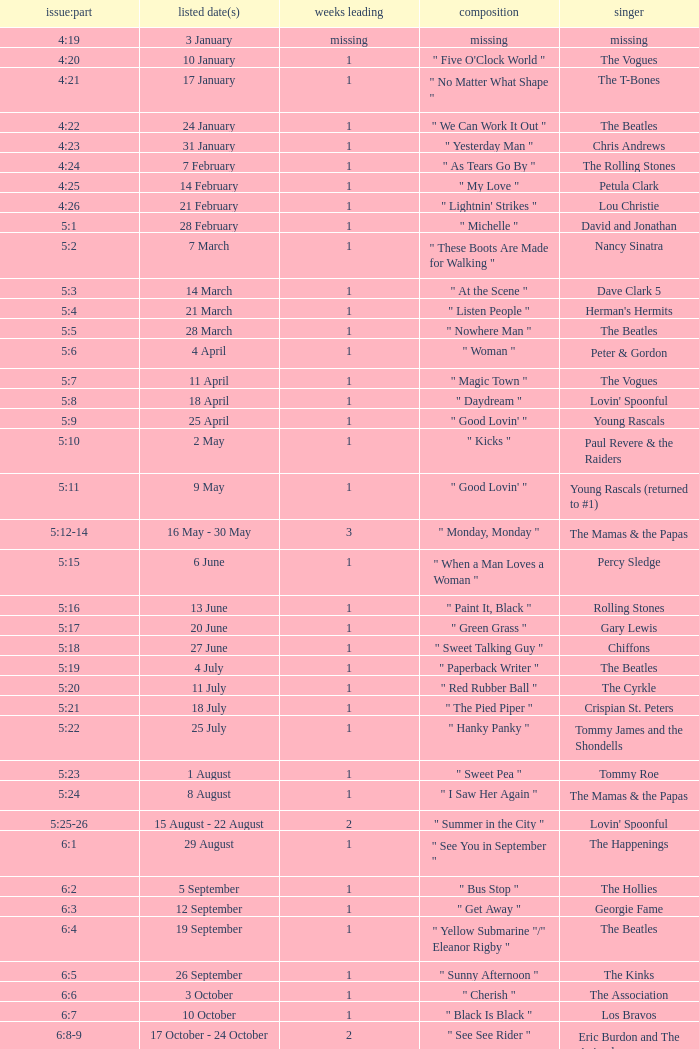An artist of the Beatles with an issue date(s) of 19 September has what as the listed weeks on top? 1.0. 